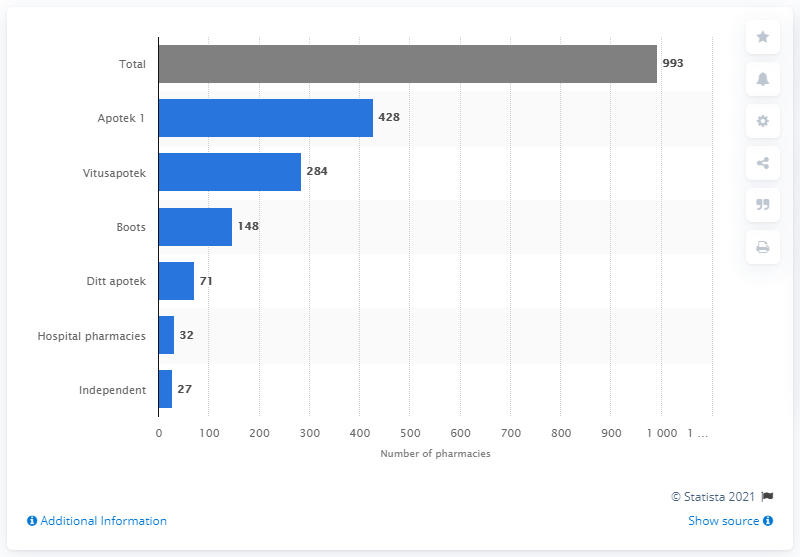Mention a couple of crucial points in this snapshot. Apotek 1 operated 428 pharmacies. As of February 1, 2021, the pharmacy chain with the highest number of pharmacies in Norway was Apotek 1. Vitusapotek was the second-largest pharmacy chain in terms of the number of pharmacies, with a significant presence across Sweden. In 2021, Apotek 1 operated 993 pharmacies in Norway. Vitusapotek had 284 pharmacies at the time. 